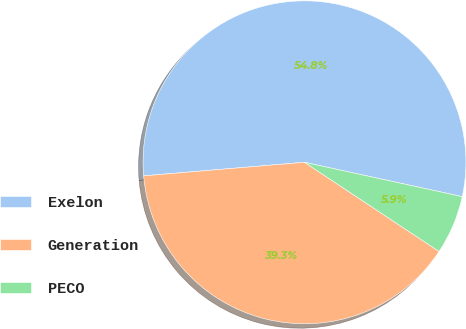<chart> <loc_0><loc_0><loc_500><loc_500><pie_chart><fcel>Exelon<fcel>Generation<fcel>PECO<nl><fcel>54.75%<fcel>39.34%<fcel>5.9%<nl></chart> 